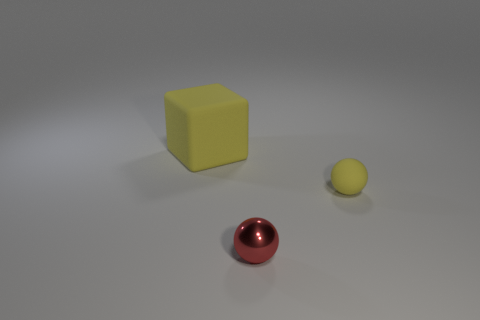Add 2 big yellow rubber objects. How many objects exist? 5 Subtract all balls. How many objects are left? 1 Subtract 0 purple cylinders. How many objects are left? 3 Subtract all brown rubber balls. Subtract all yellow spheres. How many objects are left? 2 Add 3 tiny red things. How many tiny red things are left? 4 Add 3 big yellow rubber things. How many big yellow rubber things exist? 4 